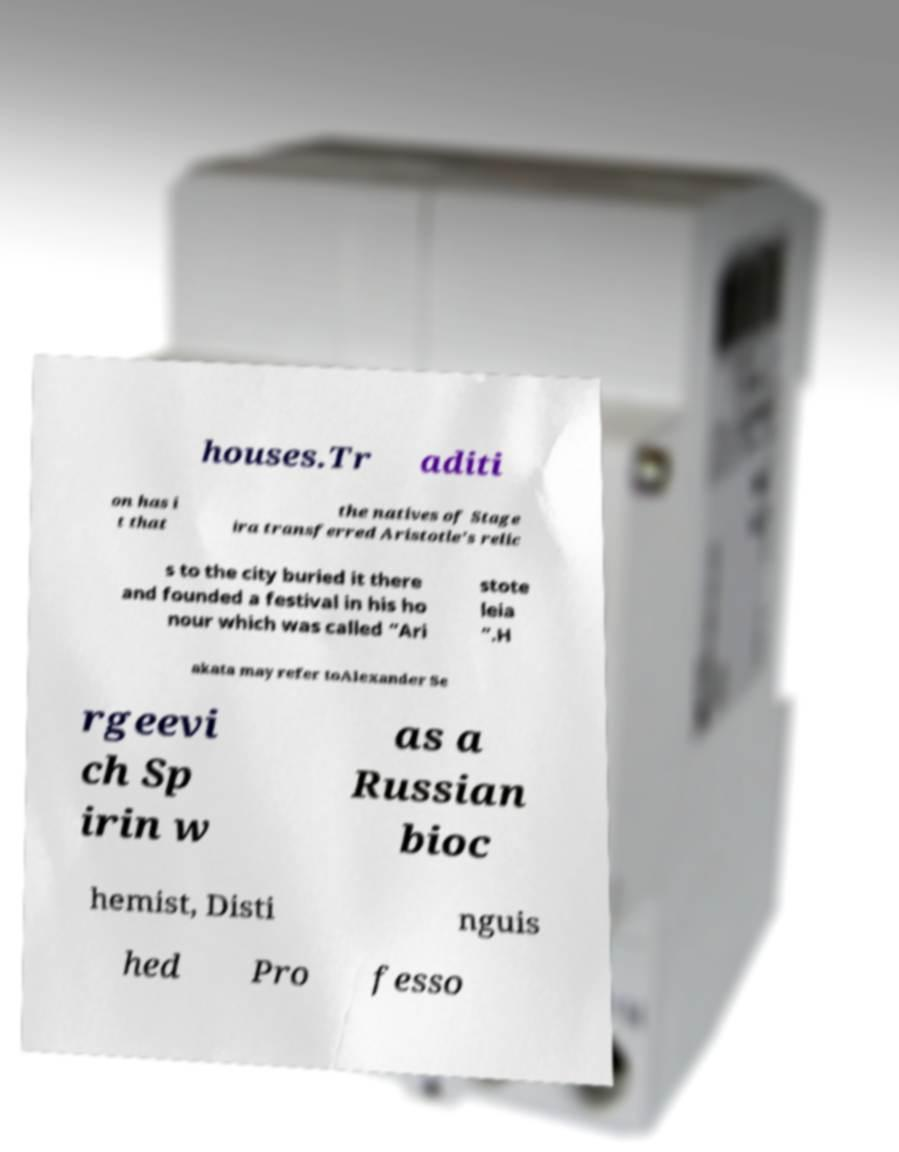Can you read and provide the text displayed in the image?This photo seems to have some interesting text. Can you extract and type it out for me? houses.Tr aditi on has i t that the natives of Stage ira transferred Aristotle's relic s to the city buried it there and founded a festival in his ho nour which was called “Ari stote leia ”.H akata may refer toAlexander Se rgeevi ch Sp irin w as a Russian bioc hemist, Disti nguis hed Pro fesso 